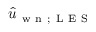<formula> <loc_0><loc_0><loc_500><loc_500>\hat { u } _ { w n ; L E S }</formula> 